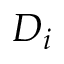Convert formula to latex. <formula><loc_0><loc_0><loc_500><loc_500>D _ { i }</formula> 